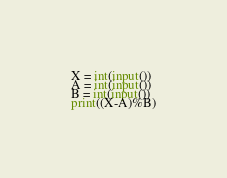Convert code to text. <code><loc_0><loc_0><loc_500><loc_500><_Python_>X = int(input())
A = int(input())
B = int(input())
print((X-A)%B)</code> 